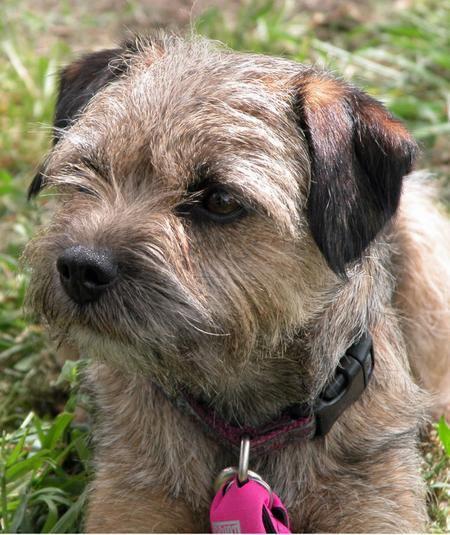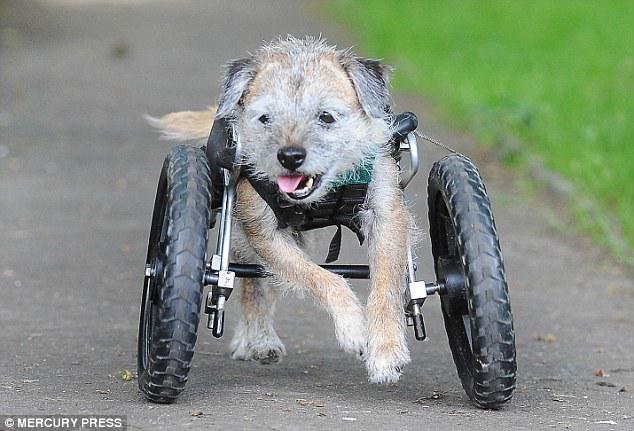The first image is the image on the left, the second image is the image on the right. Given the left and right images, does the statement "All the dogs have a visible collar on." hold true? Answer yes or no. No. The first image is the image on the left, the second image is the image on the right. Assess this claim about the two images: "a circular metal dog tag is attached to the dogs collar". Correct or not? Answer yes or no. No. 